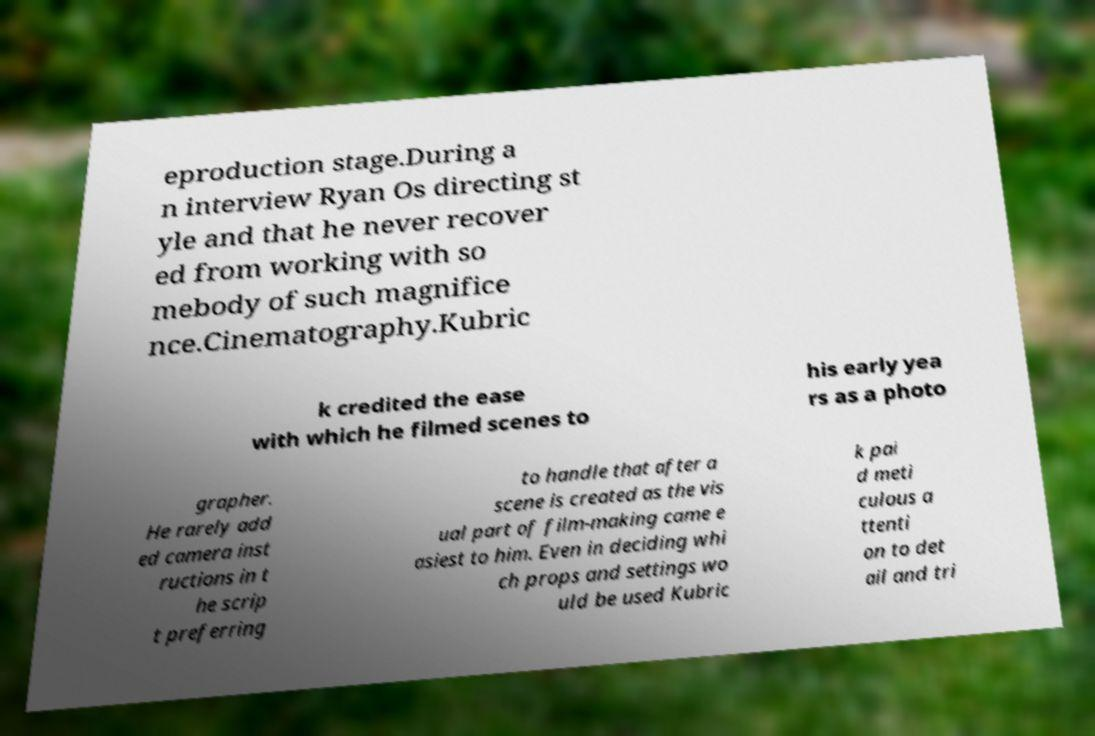Could you assist in decoding the text presented in this image and type it out clearly? eproduction stage.During a n interview Ryan Os directing st yle and that he never recover ed from working with so mebody of such magnifice nce.Cinematography.Kubric k credited the ease with which he filmed scenes to his early yea rs as a photo grapher. He rarely add ed camera inst ructions in t he scrip t preferring to handle that after a scene is created as the vis ual part of film-making came e asiest to him. Even in deciding whi ch props and settings wo uld be used Kubric k pai d meti culous a ttenti on to det ail and tri 